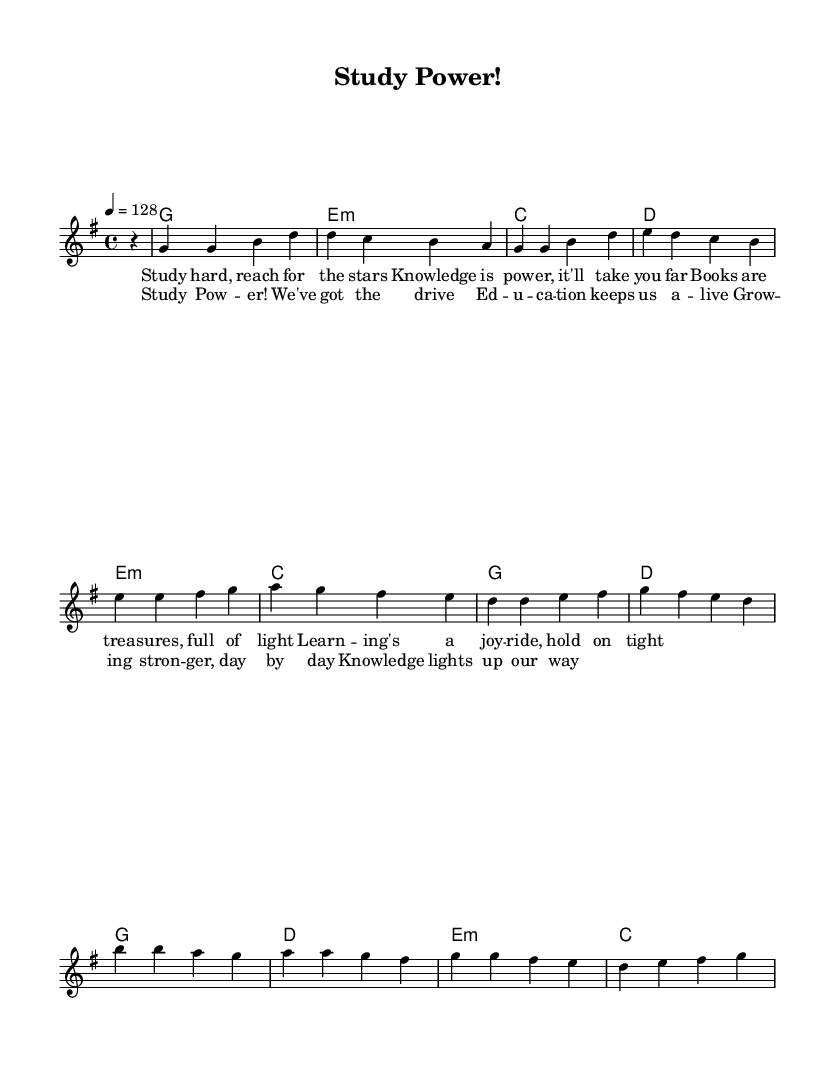What is the key signature of this music? The key signature is indicated at the beginning of the staff, where it shows one sharp, which denotes the G major scale.
Answer: G major What is the time signature of this music? The time signature is located after the key signature and shows 4 over 4, indicating four beats in each measure, with a quarter note receiving one beat.
Answer: 4/4 What is the tempo marking of this piece? The tempo marking is provided at the beginning of the score, showing "4 = 128," which indicates there are 128 beats per minute.
Answer: 128 How many measures are in the melody? By counting the distinct segments, we can identify that there are a total of 8 measures in the melody section.
Answer: 8 What type of chord is used in the first harmony? The first chord listed is a G major chord, which is represented by the letter G in the chord mode section.
Answer: G What is the theme of the lyrics in this piece? The lyrics encourage studying and emphasize the value of education, celebrating knowledge as a source of power and growth.
Answer: Education What unique characteristics make this a K-Pop track? The lyrics convey an upbeat and motivational message typical of K-Pop, combined with a lively tempo and energetic melody, which are distinct features of the genre.
Answer: Upbeat and motivational 